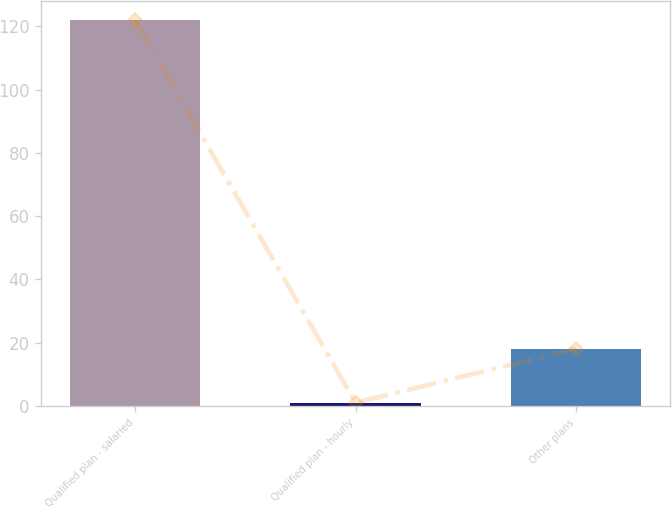Convert chart. <chart><loc_0><loc_0><loc_500><loc_500><bar_chart><fcel>Qualified plan - salaried<fcel>Qualified plan - hourly<fcel>Other plans<nl><fcel>122<fcel>1<fcel>18<nl></chart> 